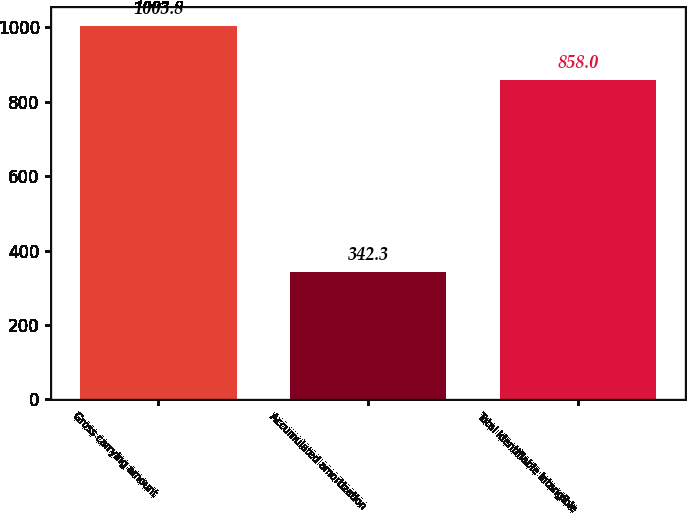Convert chart. <chart><loc_0><loc_0><loc_500><loc_500><bar_chart><fcel>Gross carrying amount<fcel>Accumulated amortization<fcel>Total identifiable intangible<nl><fcel>1003.8<fcel>342.3<fcel>858<nl></chart> 